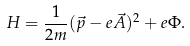<formula> <loc_0><loc_0><loc_500><loc_500>H = \frac { 1 } { 2 m } ( \vec { p } - e \vec { A } ) ^ { 2 } + e \Phi .</formula> 